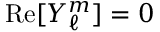Convert formula to latex. <formula><loc_0><loc_0><loc_500><loc_500>{ R e } [ Y _ { \ell } ^ { m } ] = 0</formula> 